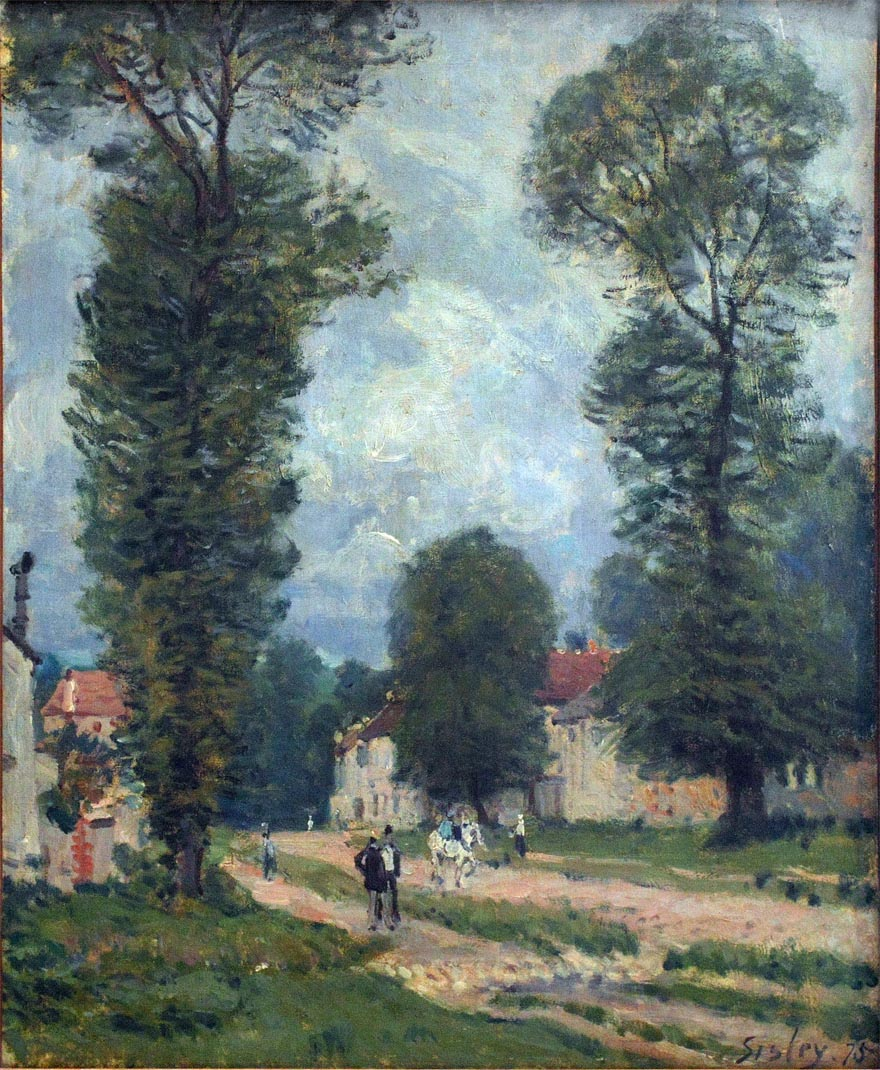If the trees could speak, what stories might they tell? If the trees in the painting could speak, they might tell tales of the changing seasons, the different generations of people they have seen passing by, and the subtle shifts in the landscape over the years. They could recount stories of children playing under their shade, lovers meeting in secret, and farmers resting beneath them after a hard day's work. They might also share the serene beauty of countless sunsets and the quiet of early mornings, painting a vivid picture of life in the countryside through the years. Could the scene be related to any famous historical event? It is unlikely that this bucolic rural scene is directly related to any major historical events, given its tranquility and focus on daily life. However, it does reflect the 19th-century rural Europe lifestyle and can be seen as part of the broader cultural history. This painting captures the essence of a time when life was simpler and closely tied to nature, which itself is a significant reflection of the period it was painted in. 